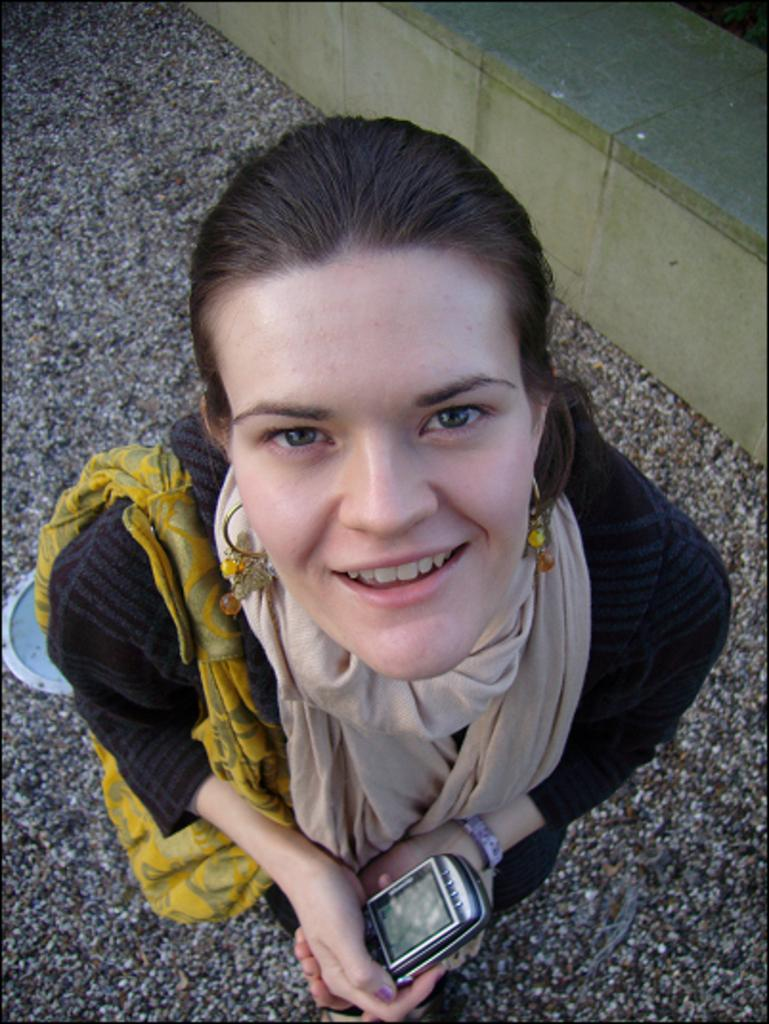What can be seen in the image? There is a person in the image. What is the person wearing? The person is wearing clothes. What is the person holding in her hands? The person is holding a phone in her hands. What type of furniture is visible in the image? There is a cement bench in the top right of the image. What type of competition is the person participating in, as seen in the image? There is no competition visible in the image; it only shows a person holding a phone and a cement bench in the background. 